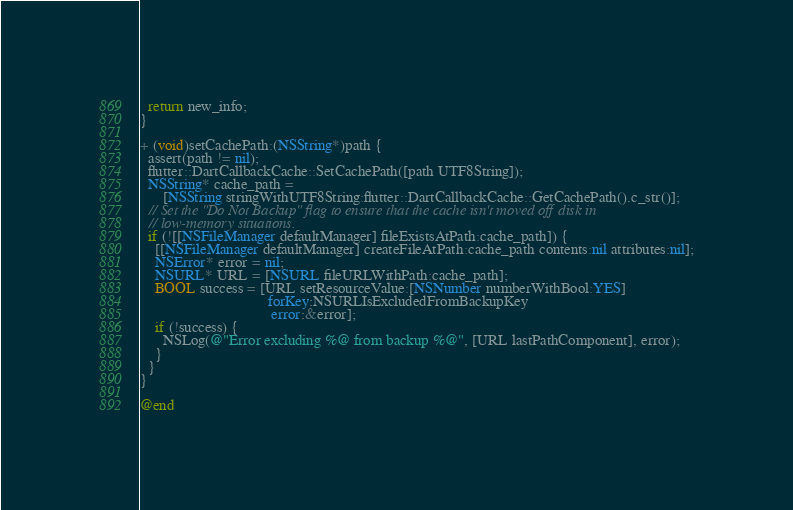<code> <loc_0><loc_0><loc_500><loc_500><_ObjectiveC_>  return new_info;
}

+ (void)setCachePath:(NSString*)path {
  assert(path != nil);
  flutter::DartCallbackCache::SetCachePath([path UTF8String]);
  NSString* cache_path =
      [NSString stringWithUTF8String:flutter::DartCallbackCache::GetCachePath().c_str()];
  // Set the "Do Not Backup" flag to ensure that the cache isn't moved off disk in
  // low-memory situations.
  if (![[NSFileManager defaultManager] fileExistsAtPath:cache_path]) {
    [[NSFileManager defaultManager] createFileAtPath:cache_path contents:nil attributes:nil];
    NSError* error = nil;
    NSURL* URL = [NSURL fileURLWithPath:cache_path];
    BOOL success = [URL setResourceValue:[NSNumber numberWithBool:YES]
                                  forKey:NSURLIsExcludedFromBackupKey
                                   error:&error];
    if (!success) {
      NSLog(@"Error excluding %@ from backup %@", [URL lastPathComponent], error);
    }
  }
}

@end
</code> 